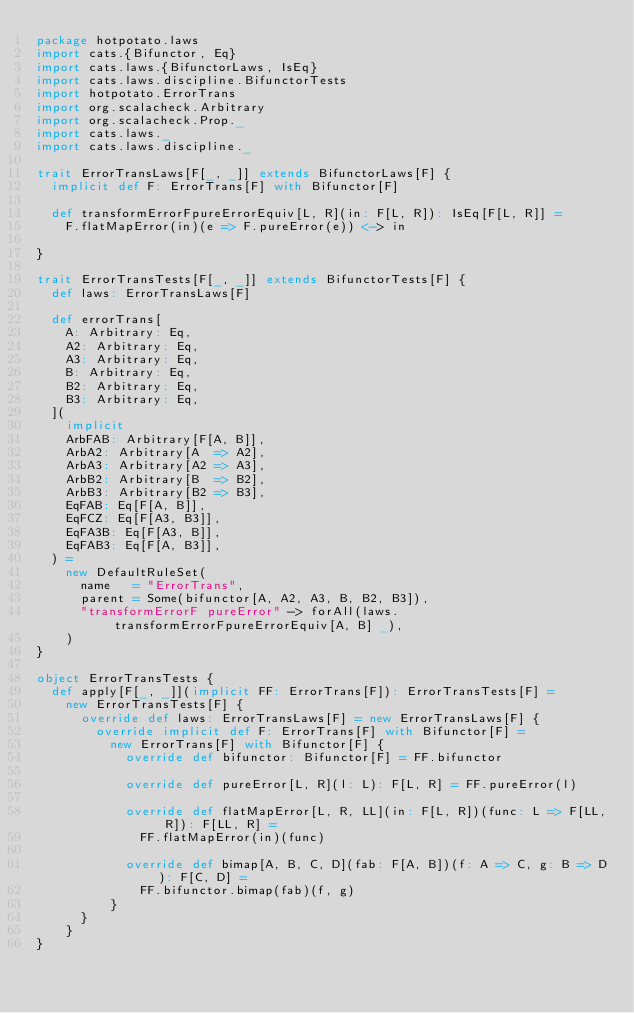Convert code to text. <code><loc_0><loc_0><loc_500><loc_500><_Scala_>package hotpotato.laws
import cats.{Bifunctor, Eq}
import cats.laws.{BifunctorLaws, IsEq}
import cats.laws.discipline.BifunctorTests
import hotpotato.ErrorTrans
import org.scalacheck.Arbitrary
import org.scalacheck.Prop._
import cats.laws._
import cats.laws.discipline._

trait ErrorTransLaws[F[_, _]] extends BifunctorLaws[F] {
  implicit def F: ErrorTrans[F] with Bifunctor[F]

  def transformErrorFpureErrorEquiv[L, R](in: F[L, R]): IsEq[F[L, R]] =
    F.flatMapError(in)(e => F.pureError(e)) <-> in

}

trait ErrorTransTests[F[_, _]] extends BifunctorTests[F] {
  def laws: ErrorTransLaws[F]

  def errorTrans[
    A: Arbitrary: Eq,
    A2: Arbitrary: Eq,
    A3: Arbitrary: Eq,
    B: Arbitrary: Eq,
    B2: Arbitrary: Eq,
    B3: Arbitrary: Eq,
  ](
    implicit
    ArbFAB: Arbitrary[F[A, B]],
    ArbA2: Arbitrary[A  => A2],
    ArbA3: Arbitrary[A2 => A3],
    ArbB2: Arbitrary[B  => B2],
    ArbB3: Arbitrary[B2 => B3],
    EqFAB: Eq[F[A, B]],
    EqFCZ: Eq[F[A3, B3]],
    EqFA3B: Eq[F[A3, B]],
    EqFAB3: Eq[F[A, B3]],
  ) =
    new DefaultRuleSet(
      name   = "ErrorTrans",
      parent = Some(bifunctor[A, A2, A3, B, B2, B3]),
      "transformErrorF pureError" -> forAll(laws.transformErrorFpureErrorEquiv[A, B] _),
    )
}

object ErrorTransTests {
  def apply[F[_, _]](implicit FF: ErrorTrans[F]): ErrorTransTests[F] =
    new ErrorTransTests[F] {
      override def laws: ErrorTransLaws[F] = new ErrorTransLaws[F] {
        override implicit def F: ErrorTrans[F] with Bifunctor[F] =
          new ErrorTrans[F] with Bifunctor[F] {
            override def bifunctor: Bifunctor[F] = FF.bifunctor

            override def pureError[L, R](l: L): F[L, R] = FF.pureError(l)

            override def flatMapError[L, R, LL](in: F[L, R])(func: L => F[LL, R]): F[LL, R] =
              FF.flatMapError(in)(func)

            override def bimap[A, B, C, D](fab: F[A, B])(f: A => C, g: B => D): F[C, D] =
              FF.bifunctor.bimap(fab)(f, g)
          }
      }
    }
}
</code> 